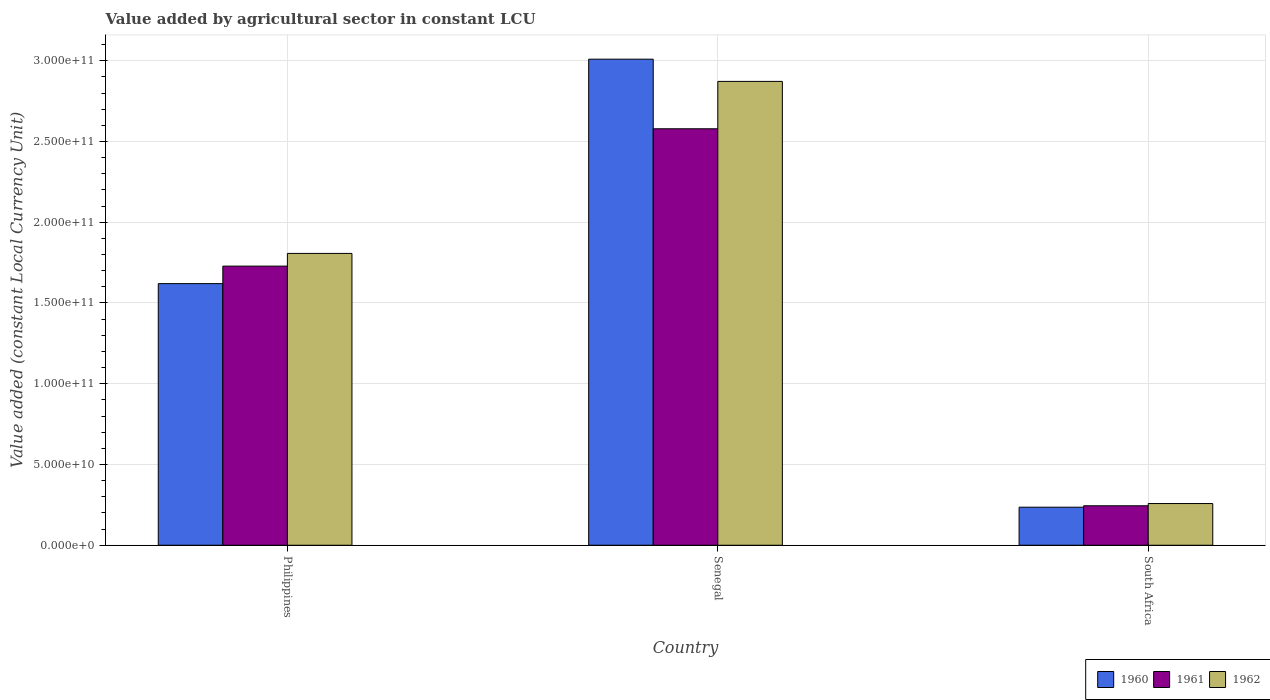Are the number of bars on each tick of the X-axis equal?
Ensure brevity in your answer.  Yes. How many bars are there on the 2nd tick from the left?
Keep it short and to the point. 3. How many bars are there on the 3rd tick from the right?
Give a very brief answer. 3. What is the label of the 3rd group of bars from the left?
Offer a very short reply. South Africa. What is the value added by agricultural sector in 1961 in South Africa?
Your answer should be very brief. 2.44e+1. Across all countries, what is the maximum value added by agricultural sector in 1962?
Offer a terse response. 2.87e+11. Across all countries, what is the minimum value added by agricultural sector in 1962?
Your answer should be very brief. 2.58e+1. In which country was the value added by agricultural sector in 1962 maximum?
Your answer should be very brief. Senegal. In which country was the value added by agricultural sector in 1962 minimum?
Provide a succinct answer. South Africa. What is the total value added by agricultural sector in 1961 in the graph?
Offer a very short reply. 4.55e+11. What is the difference between the value added by agricultural sector in 1961 in Senegal and that in South Africa?
Provide a succinct answer. 2.33e+11. What is the difference between the value added by agricultural sector in 1962 in Philippines and the value added by agricultural sector in 1960 in Senegal?
Your answer should be compact. -1.20e+11. What is the average value added by agricultural sector in 1960 per country?
Give a very brief answer. 1.62e+11. What is the difference between the value added by agricultural sector of/in 1962 and value added by agricultural sector of/in 1961 in Senegal?
Keep it short and to the point. 2.93e+1. What is the ratio of the value added by agricultural sector in 1960 in Philippines to that in Senegal?
Your answer should be compact. 0.54. Is the value added by agricultural sector in 1961 in Philippines less than that in Senegal?
Ensure brevity in your answer.  Yes. What is the difference between the highest and the second highest value added by agricultural sector in 1960?
Provide a succinct answer. -1.39e+11. What is the difference between the highest and the lowest value added by agricultural sector in 1960?
Your answer should be compact. 2.77e+11. What does the 2nd bar from the right in Philippines represents?
Your answer should be compact. 1961. Is it the case that in every country, the sum of the value added by agricultural sector in 1961 and value added by agricultural sector in 1962 is greater than the value added by agricultural sector in 1960?
Offer a terse response. Yes. How many countries are there in the graph?
Keep it short and to the point. 3. What is the difference between two consecutive major ticks on the Y-axis?
Offer a very short reply. 5.00e+1. Does the graph contain any zero values?
Keep it short and to the point. No. Where does the legend appear in the graph?
Offer a terse response. Bottom right. How are the legend labels stacked?
Provide a short and direct response. Horizontal. What is the title of the graph?
Provide a short and direct response. Value added by agricultural sector in constant LCU. What is the label or title of the Y-axis?
Your answer should be very brief. Value added (constant Local Currency Unit). What is the Value added (constant Local Currency Unit) in 1960 in Philippines?
Make the answer very short. 1.62e+11. What is the Value added (constant Local Currency Unit) of 1961 in Philippines?
Your answer should be compact. 1.73e+11. What is the Value added (constant Local Currency Unit) in 1962 in Philippines?
Ensure brevity in your answer.  1.81e+11. What is the Value added (constant Local Currency Unit) in 1960 in Senegal?
Offer a terse response. 3.01e+11. What is the Value added (constant Local Currency Unit) of 1961 in Senegal?
Provide a short and direct response. 2.58e+11. What is the Value added (constant Local Currency Unit) in 1962 in Senegal?
Your answer should be very brief. 2.87e+11. What is the Value added (constant Local Currency Unit) in 1960 in South Africa?
Provide a succinct answer. 2.36e+1. What is the Value added (constant Local Currency Unit) of 1961 in South Africa?
Offer a very short reply. 2.44e+1. What is the Value added (constant Local Currency Unit) in 1962 in South Africa?
Make the answer very short. 2.58e+1. Across all countries, what is the maximum Value added (constant Local Currency Unit) of 1960?
Your answer should be compact. 3.01e+11. Across all countries, what is the maximum Value added (constant Local Currency Unit) in 1961?
Offer a very short reply. 2.58e+11. Across all countries, what is the maximum Value added (constant Local Currency Unit) in 1962?
Keep it short and to the point. 2.87e+11. Across all countries, what is the minimum Value added (constant Local Currency Unit) in 1960?
Your answer should be compact. 2.36e+1. Across all countries, what is the minimum Value added (constant Local Currency Unit) in 1961?
Give a very brief answer. 2.44e+1. Across all countries, what is the minimum Value added (constant Local Currency Unit) of 1962?
Give a very brief answer. 2.58e+1. What is the total Value added (constant Local Currency Unit) in 1960 in the graph?
Give a very brief answer. 4.86e+11. What is the total Value added (constant Local Currency Unit) of 1961 in the graph?
Offer a terse response. 4.55e+11. What is the total Value added (constant Local Currency Unit) in 1962 in the graph?
Keep it short and to the point. 4.94e+11. What is the difference between the Value added (constant Local Currency Unit) of 1960 in Philippines and that in Senegal?
Your answer should be compact. -1.39e+11. What is the difference between the Value added (constant Local Currency Unit) of 1961 in Philippines and that in Senegal?
Offer a very short reply. -8.50e+1. What is the difference between the Value added (constant Local Currency Unit) of 1962 in Philippines and that in Senegal?
Your answer should be very brief. -1.07e+11. What is the difference between the Value added (constant Local Currency Unit) of 1960 in Philippines and that in South Africa?
Your response must be concise. 1.38e+11. What is the difference between the Value added (constant Local Currency Unit) of 1961 in Philippines and that in South Africa?
Offer a very short reply. 1.48e+11. What is the difference between the Value added (constant Local Currency Unit) in 1962 in Philippines and that in South Africa?
Provide a succinct answer. 1.55e+11. What is the difference between the Value added (constant Local Currency Unit) in 1960 in Senegal and that in South Africa?
Ensure brevity in your answer.  2.77e+11. What is the difference between the Value added (constant Local Currency Unit) in 1961 in Senegal and that in South Africa?
Your response must be concise. 2.33e+11. What is the difference between the Value added (constant Local Currency Unit) in 1962 in Senegal and that in South Africa?
Your answer should be very brief. 2.61e+11. What is the difference between the Value added (constant Local Currency Unit) in 1960 in Philippines and the Value added (constant Local Currency Unit) in 1961 in Senegal?
Your answer should be compact. -9.59e+1. What is the difference between the Value added (constant Local Currency Unit) of 1960 in Philippines and the Value added (constant Local Currency Unit) of 1962 in Senegal?
Your response must be concise. -1.25e+11. What is the difference between the Value added (constant Local Currency Unit) of 1961 in Philippines and the Value added (constant Local Currency Unit) of 1962 in Senegal?
Offer a very short reply. -1.14e+11. What is the difference between the Value added (constant Local Currency Unit) of 1960 in Philippines and the Value added (constant Local Currency Unit) of 1961 in South Africa?
Provide a succinct answer. 1.38e+11. What is the difference between the Value added (constant Local Currency Unit) in 1960 in Philippines and the Value added (constant Local Currency Unit) in 1962 in South Africa?
Provide a succinct answer. 1.36e+11. What is the difference between the Value added (constant Local Currency Unit) of 1961 in Philippines and the Value added (constant Local Currency Unit) of 1962 in South Africa?
Your response must be concise. 1.47e+11. What is the difference between the Value added (constant Local Currency Unit) of 1960 in Senegal and the Value added (constant Local Currency Unit) of 1961 in South Africa?
Provide a succinct answer. 2.77e+11. What is the difference between the Value added (constant Local Currency Unit) of 1960 in Senegal and the Value added (constant Local Currency Unit) of 1962 in South Africa?
Give a very brief answer. 2.75e+11. What is the difference between the Value added (constant Local Currency Unit) of 1961 in Senegal and the Value added (constant Local Currency Unit) of 1962 in South Africa?
Ensure brevity in your answer.  2.32e+11. What is the average Value added (constant Local Currency Unit) of 1960 per country?
Your answer should be compact. 1.62e+11. What is the average Value added (constant Local Currency Unit) of 1961 per country?
Your answer should be very brief. 1.52e+11. What is the average Value added (constant Local Currency Unit) in 1962 per country?
Provide a succinct answer. 1.65e+11. What is the difference between the Value added (constant Local Currency Unit) in 1960 and Value added (constant Local Currency Unit) in 1961 in Philippines?
Give a very brief answer. -1.08e+1. What is the difference between the Value added (constant Local Currency Unit) of 1960 and Value added (constant Local Currency Unit) of 1962 in Philippines?
Make the answer very short. -1.87e+1. What is the difference between the Value added (constant Local Currency Unit) in 1961 and Value added (constant Local Currency Unit) in 1962 in Philippines?
Offer a very short reply. -7.86e+09. What is the difference between the Value added (constant Local Currency Unit) of 1960 and Value added (constant Local Currency Unit) of 1961 in Senegal?
Offer a very short reply. 4.31e+1. What is the difference between the Value added (constant Local Currency Unit) of 1960 and Value added (constant Local Currency Unit) of 1962 in Senegal?
Your answer should be compact. 1.38e+1. What is the difference between the Value added (constant Local Currency Unit) of 1961 and Value added (constant Local Currency Unit) of 1962 in Senegal?
Provide a succinct answer. -2.93e+1. What is the difference between the Value added (constant Local Currency Unit) of 1960 and Value added (constant Local Currency Unit) of 1961 in South Africa?
Offer a terse response. -8.75e+08. What is the difference between the Value added (constant Local Currency Unit) in 1960 and Value added (constant Local Currency Unit) in 1962 in South Africa?
Your response must be concise. -2.26e+09. What is the difference between the Value added (constant Local Currency Unit) of 1961 and Value added (constant Local Currency Unit) of 1962 in South Africa?
Offer a terse response. -1.39e+09. What is the ratio of the Value added (constant Local Currency Unit) of 1960 in Philippines to that in Senegal?
Your answer should be compact. 0.54. What is the ratio of the Value added (constant Local Currency Unit) of 1961 in Philippines to that in Senegal?
Your answer should be compact. 0.67. What is the ratio of the Value added (constant Local Currency Unit) of 1962 in Philippines to that in Senegal?
Offer a very short reply. 0.63. What is the ratio of the Value added (constant Local Currency Unit) in 1960 in Philippines to that in South Africa?
Make the answer very short. 6.88. What is the ratio of the Value added (constant Local Currency Unit) in 1961 in Philippines to that in South Africa?
Offer a very short reply. 7.07. What is the ratio of the Value added (constant Local Currency Unit) of 1962 in Philippines to that in South Africa?
Your response must be concise. 7. What is the ratio of the Value added (constant Local Currency Unit) in 1960 in Senegal to that in South Africa?
Make the answer very short. 12.77. What is the ratio of the Value added (constant Local Currency Unit) of 1961 in Senegal to that in South Africa?
Offer a terse response. 10.55. What is the ratio of the Value added (constant Local Currency Unit) in 1962 in Senegal to that in South Africa?
Your answer should be compact. 11.12. What is the difference between the highest and the second highest Value added (constant Local Currency Unit) in 1960?
Ensure brevity in your answer.  1.39e+11. What is the difference between the highest and the second highest Value added (constant Local Currency Unit) in 1961?
Ensure brevity in your answer.  8.50e+1. What is the difference between the highest and the second highest Value added (constant Local Currency Unit) in 1962?
Offer a very short reply. 1.07e+11. What is the difference between the highest and the lowest Value added (constant Local Currency Unit) in 1960?
Make the answer very short. 2.77e+11. What is the difference between the highest and the lowest Value added (constant Local Currency Unit) of 1961?
Keep it short and to the point. 2.33e+11. What is the difference between the highest and the lowest Value added (constant Local Currency Unit) of 1962?
Offer a terse response. 2.61e+11. 